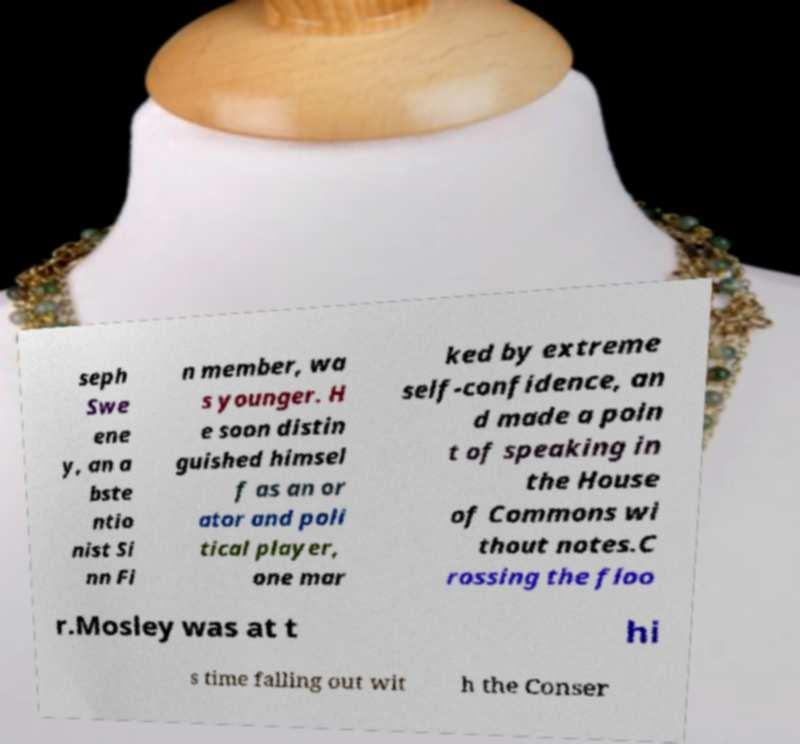Can you read and provide the text displayed in the image?This photo seems to have some interesting text. Can you extract and type it out for me? seph Swe ene y, an a bste ntio nist Si nn Fi n member, wa s younger. H e soon distin guished himsel f as an or ator and poli tical player, one mar ked by extreme self-confidence, an d made a poin t of speaking in the House of Commons wi thout notes.C rossing the floo r.Mosley was at t hi s time falling out wit h the Conser 